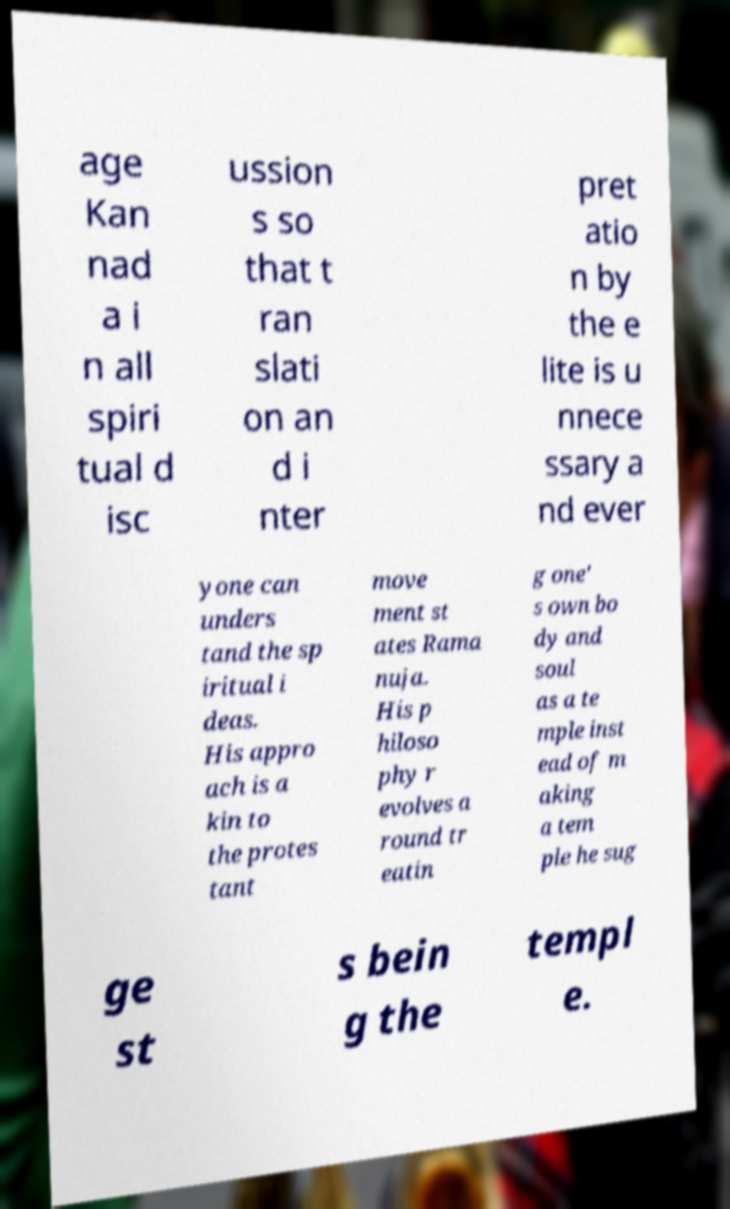For documentation purposes, I need the text within this image transcribed. Could you provide that? age Kan nad a i n all spiri tual d isc ussion s so that t ran slati on an d i nter pret atio n by the e lite is u nnece ssary a nd ever yone can unders tand the sp iritual i deas. His appro ach is a kin to the protes tant move ment st ates Rama nuja. His p hiloso phy r evolves a round tr eatin g one' s own bo dy and soul as a te mple inst ead of m aking a tem ple he sug ge st s bein g the templ e. 